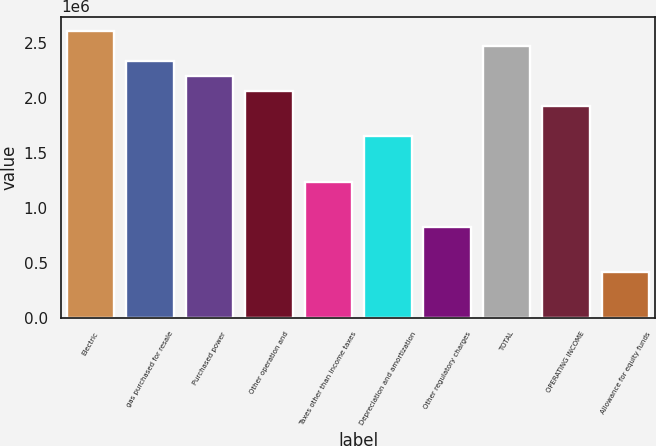<chart> <loc_0><loc_0><loc_500><loc_500><bar_chart><fcel>Electric<fcel>gas purchased for resale<fcel>Purchased power<fcel>Other operation and<fcel>Taxes other than income taxes<fcel>Depreciation and amortization<fcel>Other regulatory charges<fcel>TOTAL<fcel>OPERATING INCOME<fcel>Allowance for equity funds<nl><fcel>2.60741e+06<fcel>2.33306e+06<fcel>2.19588e+06<fcel>2.0587e+06<fcel>1.23562e+06<fcel>1.64716e+06<fcel>824086<fcel>2.47023e+06<fcel>1.92152e+06<fcel>412548<nl></chart> 